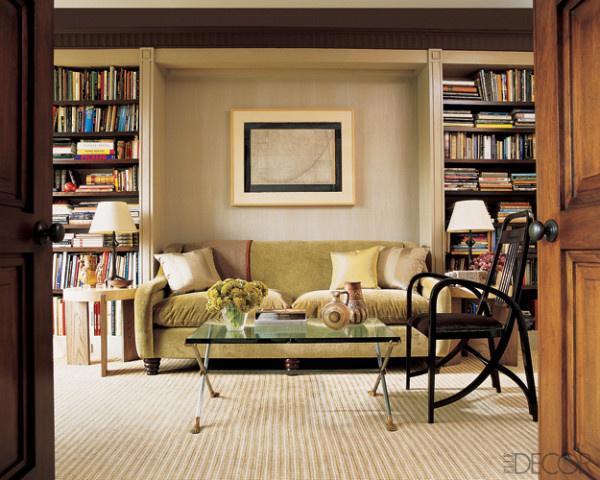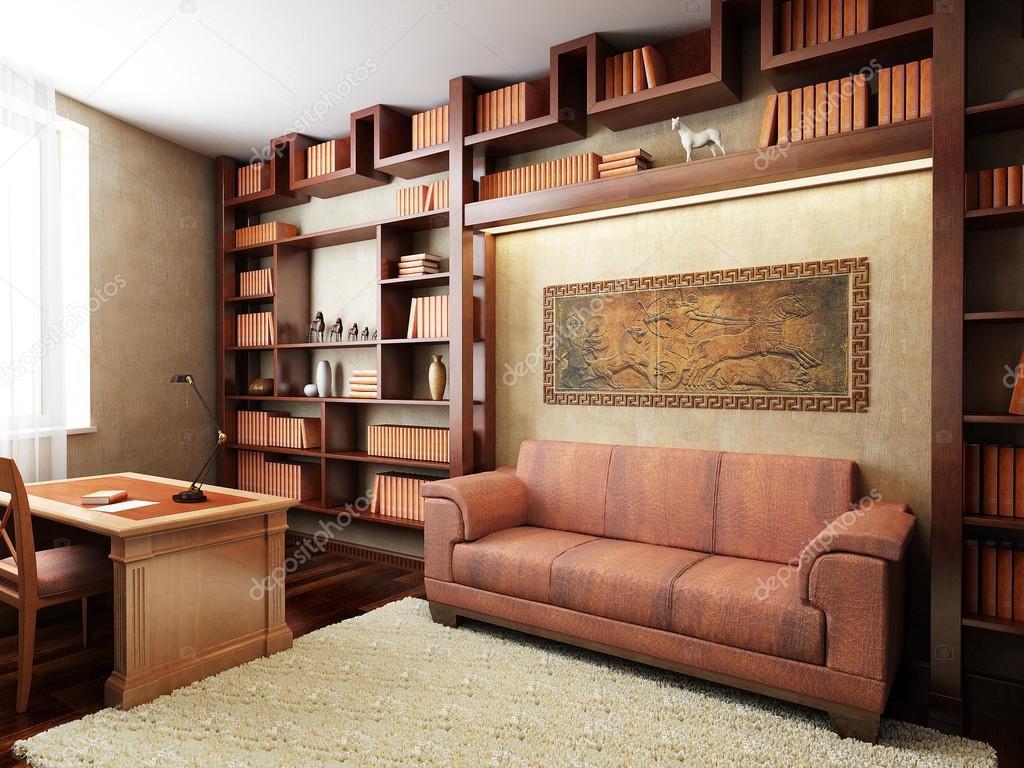The first image is the image on the left, the second image is the image on the right. For the images shown, is this caption "One of the sofas has no coffee table before it in one of the images." true? Answer yes or no. Yes. The first image is the image on the left, the second image is the image on the right. Evaluate the accuracy of this statement regarding the images: "Each image shows a single piece of art mounted on the wall behind a sofa flanked by bookshelves.". Is it true? Answer yes or no. Yes. 